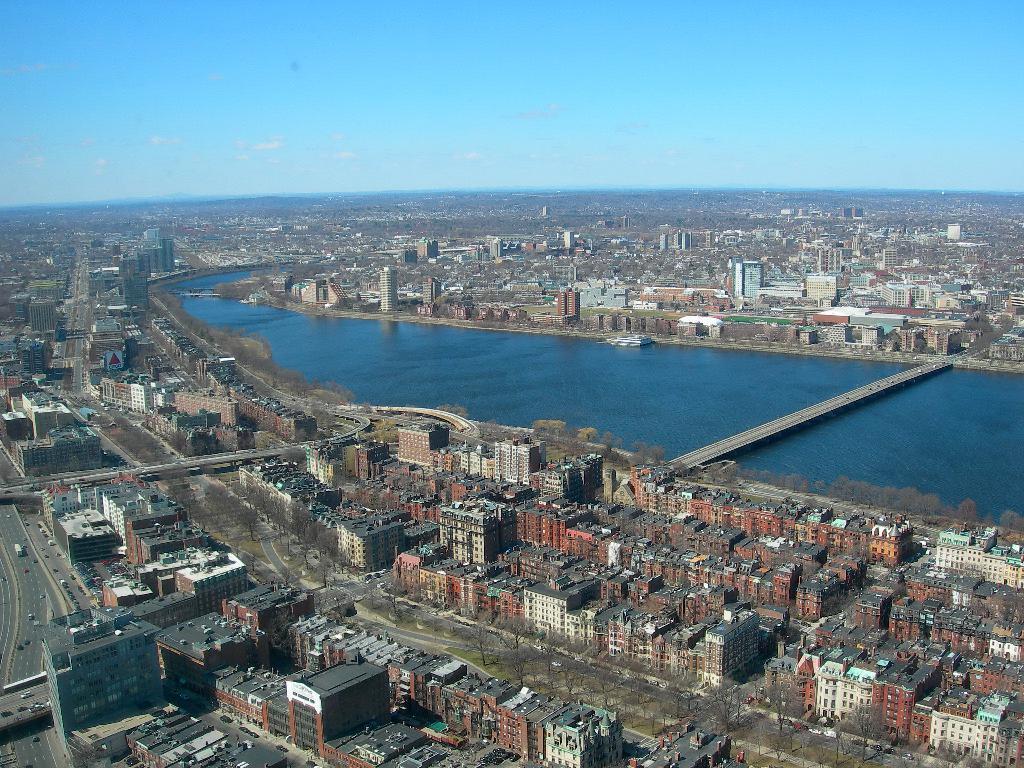How would you summarize this image in a sentence or two? In this picture we can observe many buildings. There is a river flowing. We can observe a bridge across the river. In the background there is a sky. 